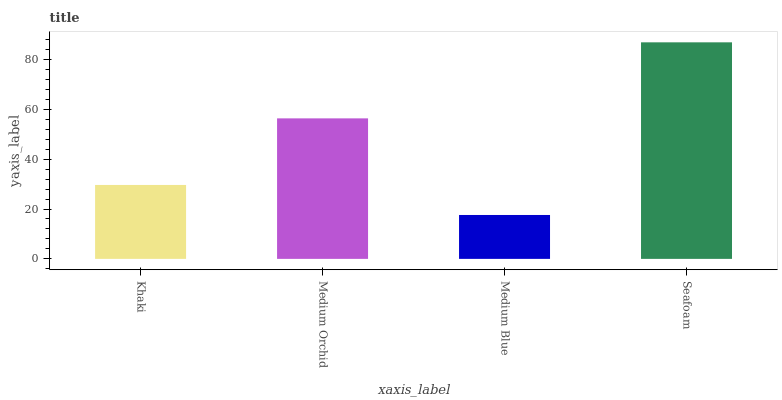Is Medium Orchid the minimum?
Answer yes or no. No. Is Medium Orchid the maximum?
Answer yes or no. No. Is Medium Orchid greater than Khaki?
Answer yes or no. Yes. Is Khaki less than Medium Orchid?
Answer yes or no. Yes. Is Khaki greater than Medium Orchid?
Answer yes or no. No. Is Medium Orchid less than Khaki?
Answer yes or no. No. Is Medium Orchid the high median?
Answer yes or no. Yes. Is Khaki the low median?
Answer yes or no. Yes. Is Seafoam the high median?
Answer yes or no. No. Is Seafoam the low median?
Answer yes or no. No. 